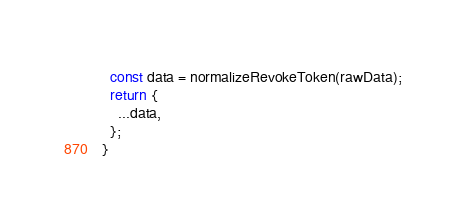<code> <loc_0><loc_0><loc_500><loc_500><_JavaScript_>  const data = normalizeRevokeToken(rawData);
  return {
    ...data,
  };
}
</code> 